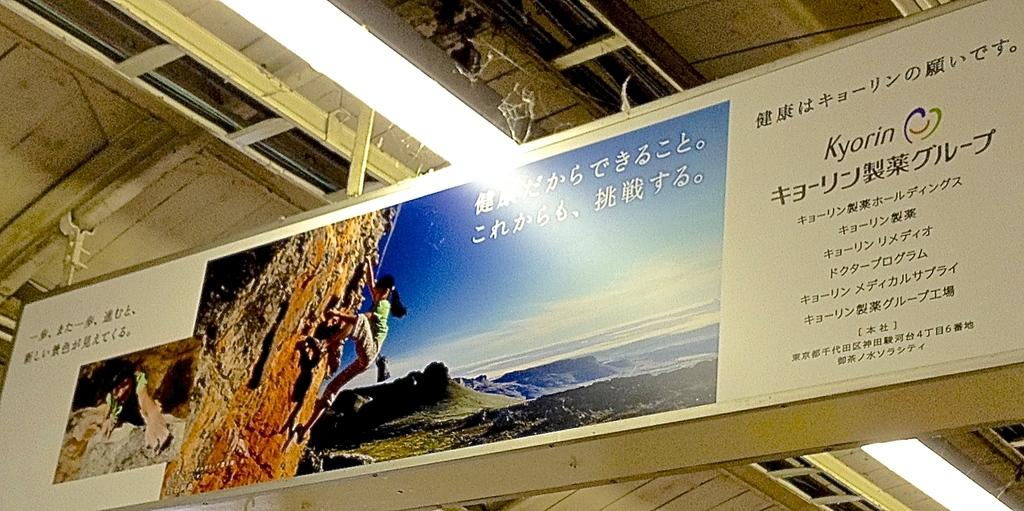<image>
Create a compact narrative representing the image presented. Chinese banner with Kyorin wrote on it also 